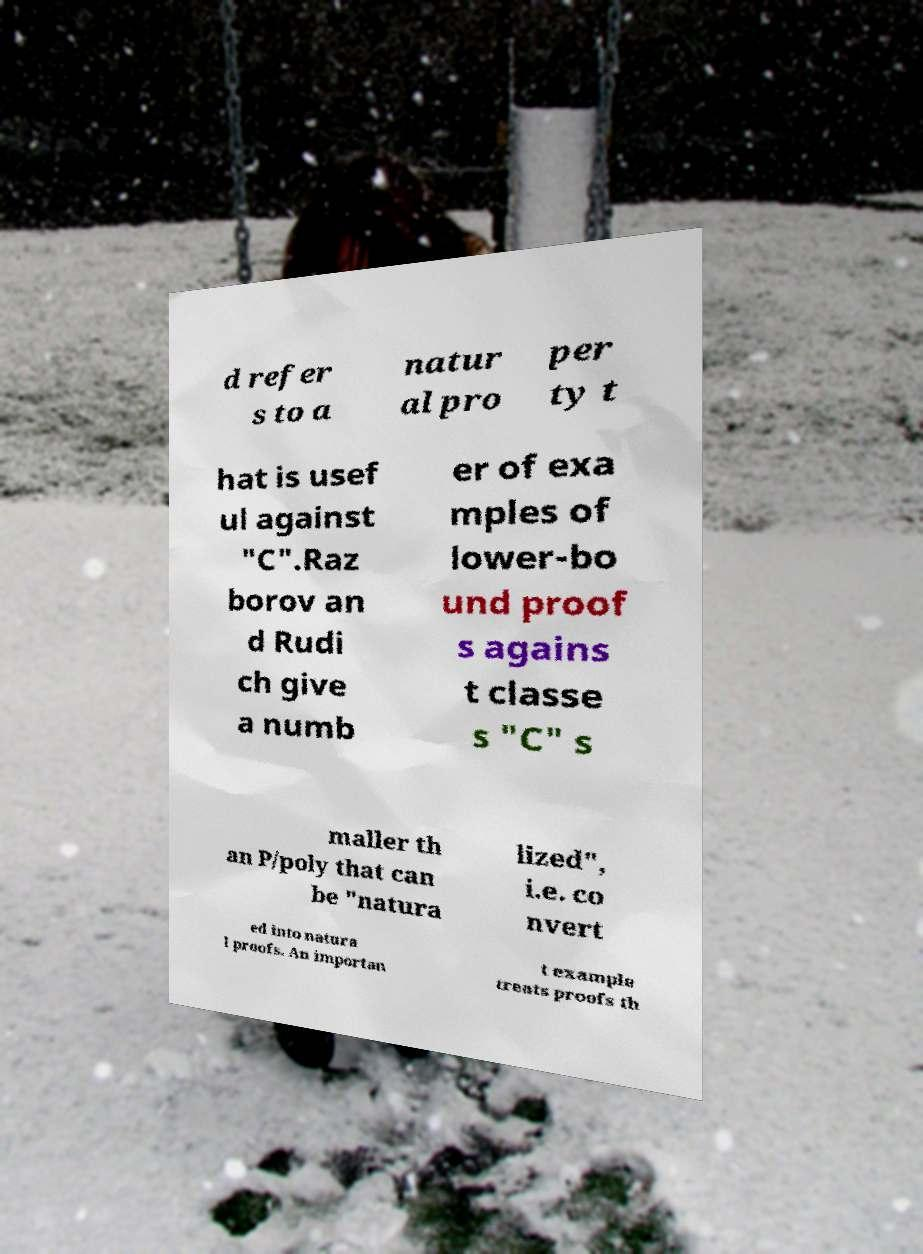There's text embedded in this image that I need extracted. Can you transcribe it verbatim? d refer s to a natur al pro per ty t hat is usef ul against "C".Raz borov an d Rudi ch give a numb er of exa mples of lower-bo und proof s agains t classe s "C" s maller th an P/poly that can be "natura lized", i.e. co nvert ed into natura l proofs. An importan t example treats proofs th 